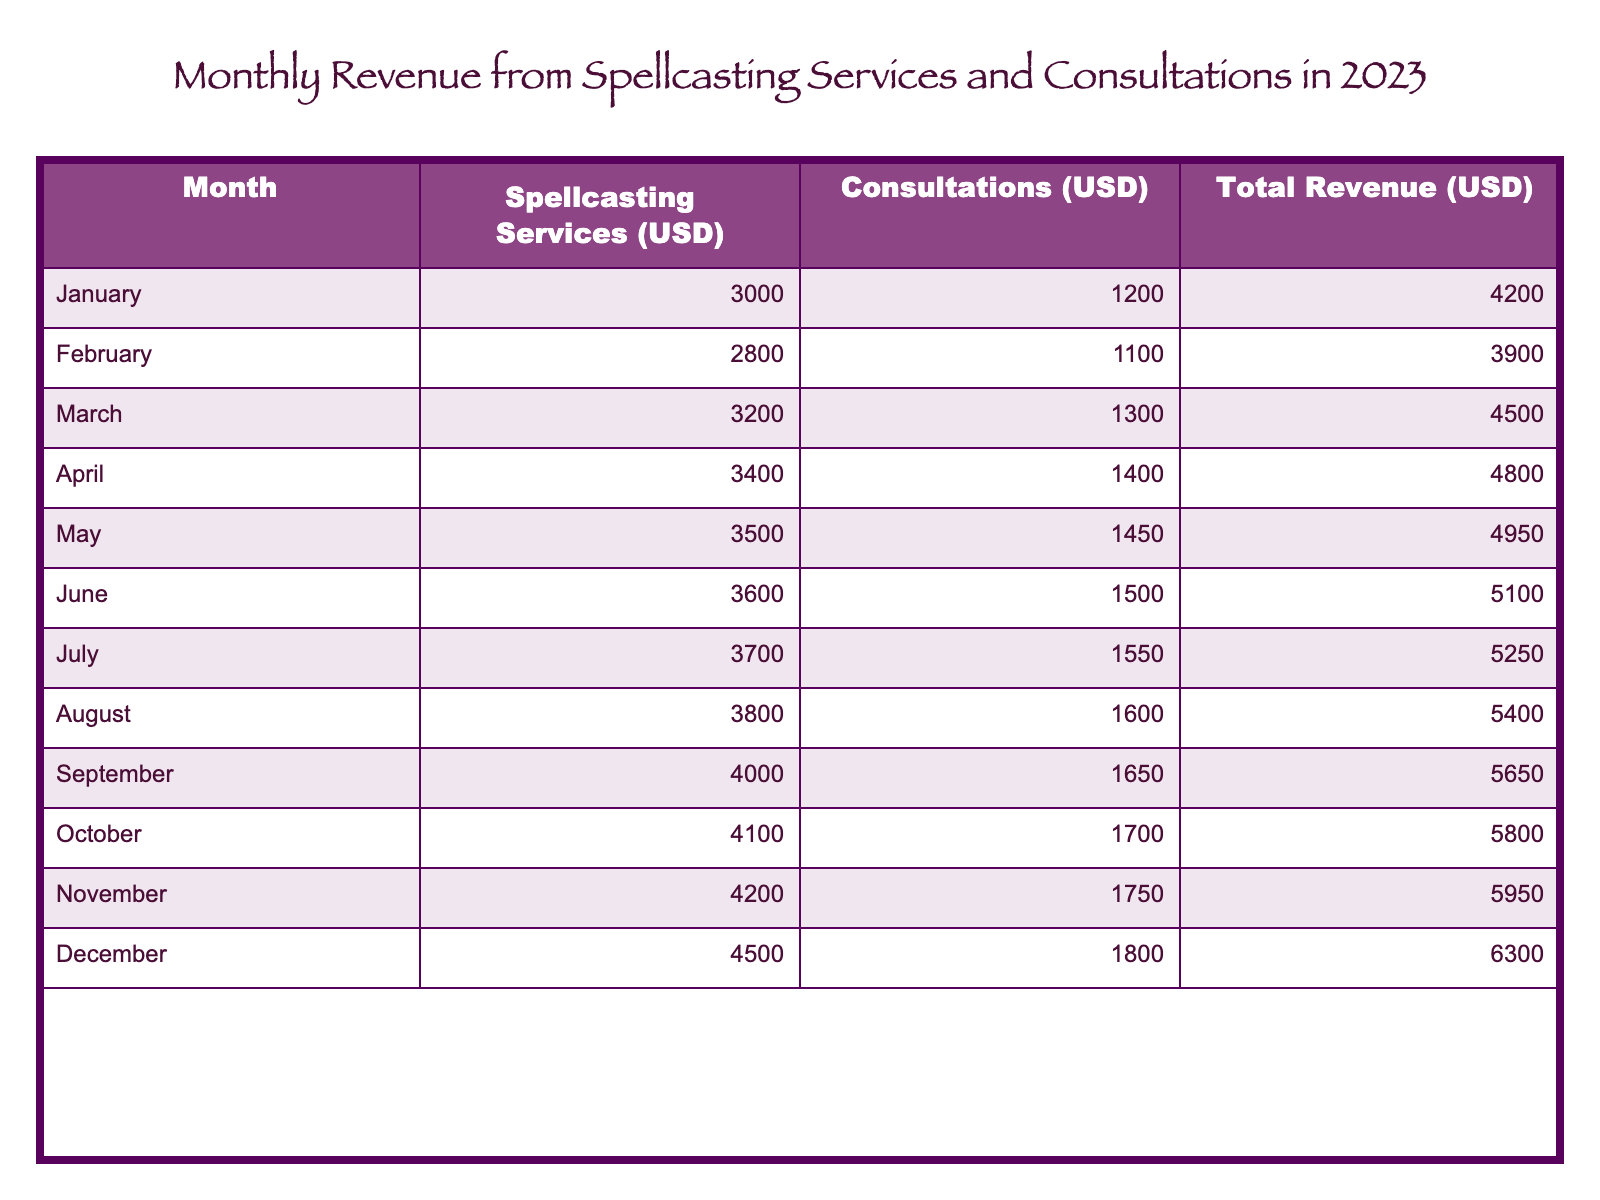What was the total revenue in March? The table shows the revenue for March clearly listed. It states that the total revenue for March is 4500 USD.
Answer: 4500 USD In which month was the revenue from spellcasting services the highest? By scanning the Spellcasting Services column, we find that the highest value under this category is 4500 USD, which occurs in December.
Answer: December What is the average amount of consultation revenue for the first half of the year (January to June)? The consultation revenues from January to June are 1200, 1100, 1300, 1400, 1450, and 1500 USD. Summing these gives 1200 + 1100 + 1300 + 1400 + 1450 + 1500 = 7950 USD. There are 6 months, so the average is 7950 / 6 = 1325 USD.
Answer: 1325 USD Did the total revenue increase every month throughout the year? To determine this, we need to compare the total revenue of each month sequentially. The total revenue starts at 4200 USD in January and increases every month to reach 6300 USD in December, confirming that revenue increased every month.
Answer: Yes What was the percentage increase in total revenue from January to December? The total revenue in January is 4200 USD, and in December it is 6300 USD. To find the percentage increase, subtract January's revenue from December's to get 6300 - 4200 = 2100 USD. Then divide by January's revenue: 2100 / 4200 = 0.5, and multiplying by 100 gives a 50% increase.
Answer: 50% 